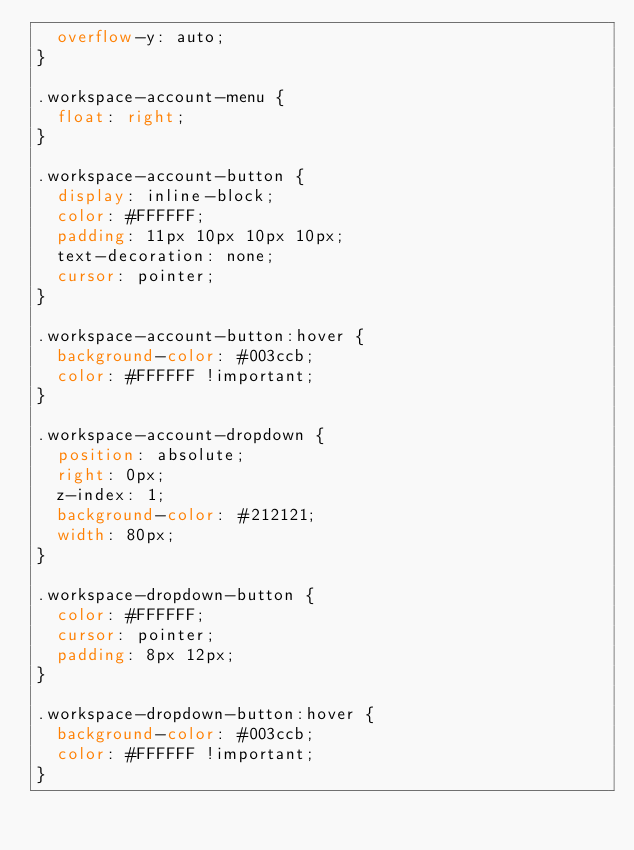Convert code to text. <code><loc_0><loc_0><loc_500><loc_500><_CSS_>  overflow-y: auto; 
}

.workspace-account-menu {
  float: right;
}

.workspace-account-button {
  display: inline-block;
  color: #FFFFFF;
  padding: 11px 10px 10px 10px;
  text-decoration: none;
  cursor: pointer;
}

.workspace-account-button:hover {
  background-color: #003ccb;
  color: #FFFFFF !important;
}

.workspace-account-dropdown {
  position: absolute;
  right: 0px;
  z-index: 1;
  background-color: #212121;
  width: 80px;
}

.workspace-dropdown-button {
  color: #FFFFFF;
  cursor: pointer;
  padding: 8px 12px;
}

.workspace-dropdown-button:hover {
  background-color: #003ccb;
  color: #FFFFFF !important;
}</code> 